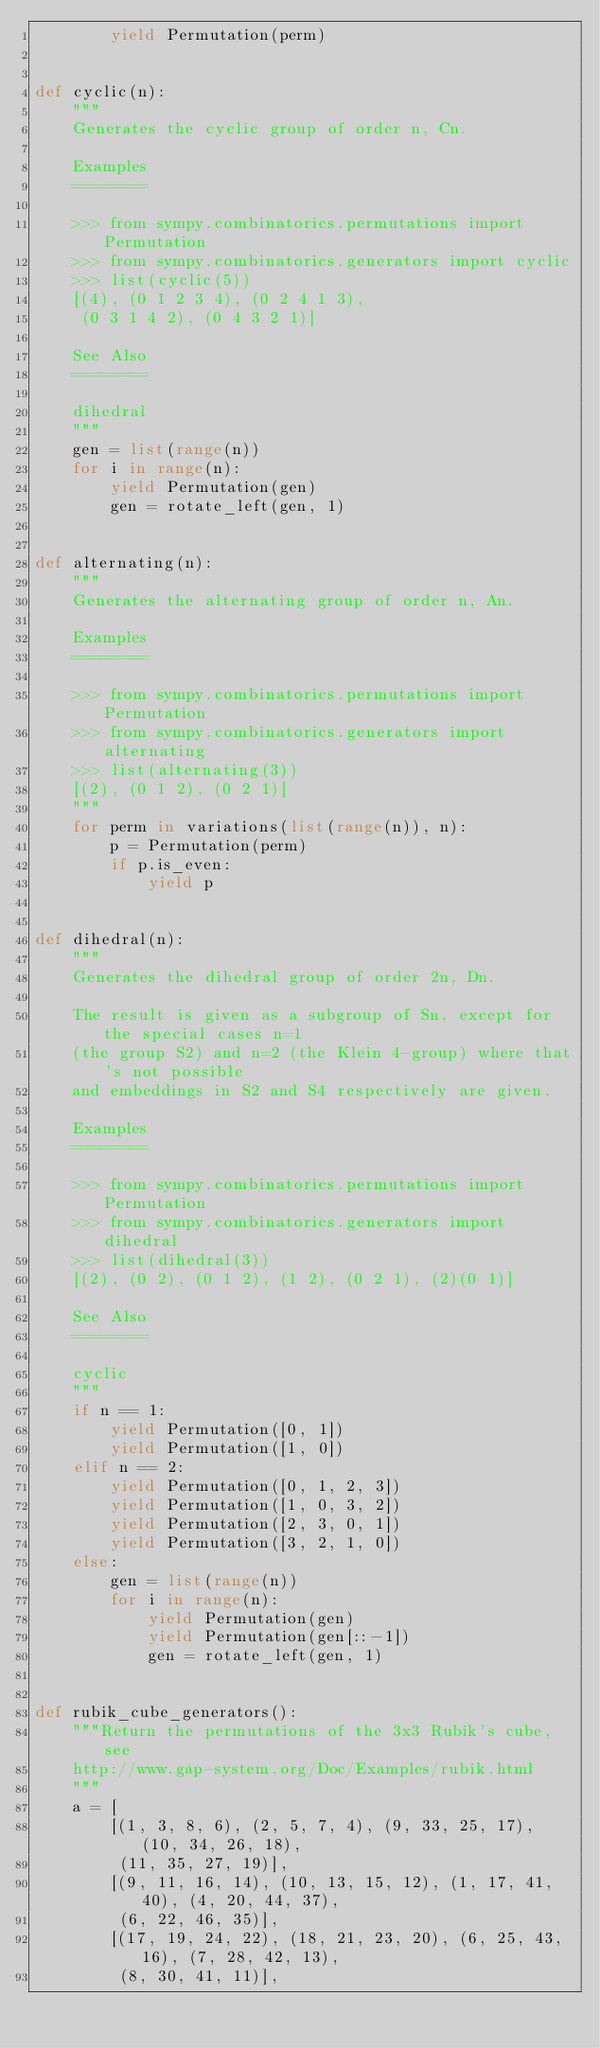<code> <loc_0><loc_0><loc_500><loc_500><_Python_>        yield Permutation(perm)


def cyclic(n):
    """
    Generates the cyclic group of order n, Cn.

    Examples
    ========

    >>> from sympy.combinatorics.permutations import Permutation
    >>> from sympy.combinatorics.generators import cyclic
    >>> list(cyclic(5))
    [(4), (0 1 2 3 4), (0 2 4 1 3),
     (0 3 1 4 2), (0 4 3 2 1)]

    See Also
    ========

    dihedral
    """
    gen = list(range(n))
    for i in range(n):
        yield Permutation(gen)
        gen = rotate_left(gen, 1)


def alternating(n):
    """
    Generates the alternating group of order n, An.

    Examples
    ========

    >>> from sympy.combinatorics.permutations import Permutation
    >>> from sympy.combinatorics.generators import alternating
    >>> list(alternating(3))
    [(2), (0 1 2), (0 2 1)]
    """
    for perm in variations(list(range(n)), n):
        p = Permutation(perm)
        if p.is_even:
            yield p


def dihedral(n):
    """
    Generates the dihedral group of order 2n, Dn.

    The result is given as a subgroup of Sn, except for the special cases n=1
    (the group S2) and n=2 (the Klein 4-group) where that's not possible
    and embeddings in S2 and S4 respectively are given.

    Examples
    ========

    >>> from sympy.combinatorics.permutations import Permutation
    >>> from sympy.combinatorics.generators import dihedral
    >>> list(dihedral(3))
    [(2), (0 2), (0 1 2), (1 2), (0 2 1), (2)(0 1)]

    See Also
    ========

    cyclic
    """
    if n == 1:
        yield Permutation([0, 1])
        yield Permutation([1, 0])
    elif n == 2:
        yield Permutation([0, 1, 2, 3])
        yield Permutation([1, 0, 3, 2])
        yield Permutation([2, 3, 0, 1])
        yield Permutation([3, 2, 1, 0])
    else:
        gen = list(range(n))
        for i in range(n):
            yield Permutation(gen)
            yield Permutation(gen[::-1])
            gen = rotate_left(gen, 1)


def rubik_cube_generators():
    """Return the permutations of the 3x3 Rubik's cube, see
    http://www.gap-system.org/Doc/Examples/rubik.html
    """
    a = [
        [(1, 3, 8, 6), (2, 5, 7, 4), (9, 33, 25, 17), (10, 34, 26, 18),
         (11, 35, 27, 19)],
        [(9, 11, 16, 14), (10, 13, 15, 12), (1, 17, 41, 40), (4, 20, 44, 37),
         (6, 22, 46, 35)],
        [(17, 19, 24, 22), (18, 21, 23, 20), (6, 25, 43, 16), (7, 28, 42, 13),
         (8, 30, 41, 11)],</code> 